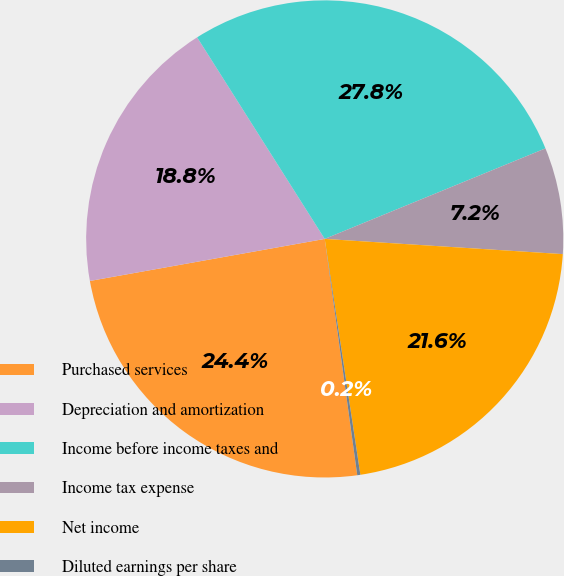Convert chart to OTSL. <chart><loc_0><loc_0><loc_500><loc_500><pie_chart><fcel>Purchased services<fcel>Depreciation and amortization<fcel>Income before income taxes and<fcel>Income tax expense<fcel>Net income<fcel>Diluted earnings per share<nl><fcel>24.36%<fcel>18.84%<fcel>27.79%<fcel>7.21%<fcel>21.6%<fcel>0.21%<nl></chart> 